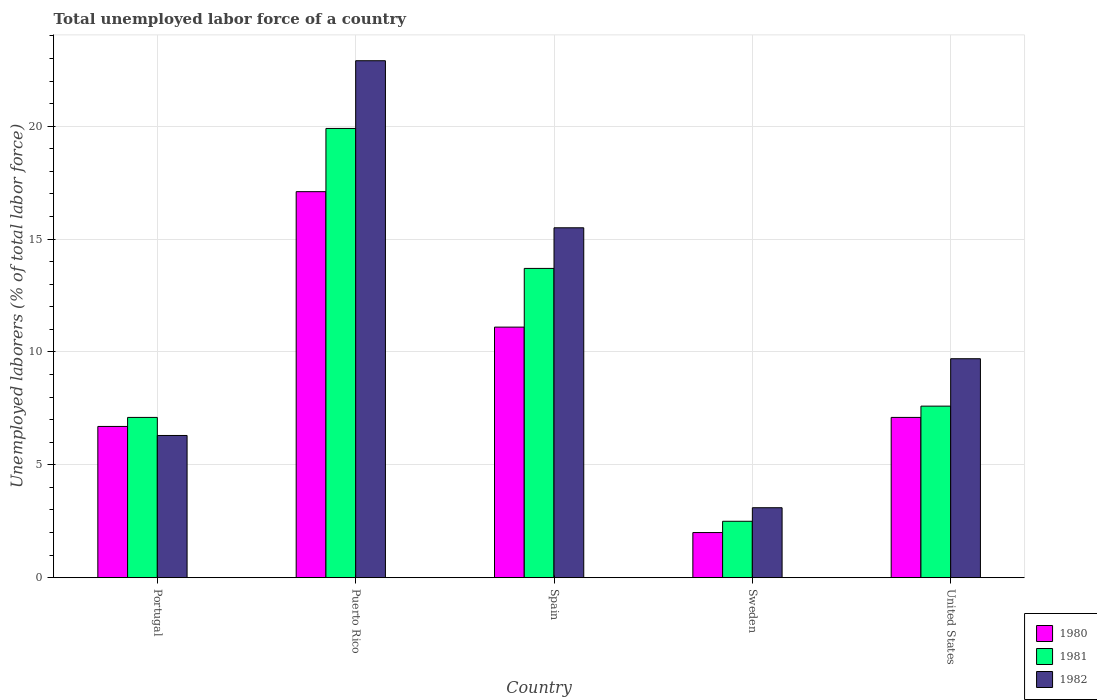Are the number of bars per tick equal to the number of legend labels?
Ensure brevity in your answer.  Yes. Are the number of bars on each tick of the X-axis equal?
Make the answer very short. Yes. How many bars are there on the 4th tick from the left?
Your response must be concise. 3. In how many cases, is the number of bars for a given country not equal to the number of legend labels?
Provide a short and direct response. 0. What is the total unemployed labor force in 1982 in Portugal?
Keep it short and to the point. 6.3. Across all countries, what is the maximum total unemployed labor force in 1980?
Your response must be concise. 17.1. In which country was the total unemployed labor force in 1982 maximum?
Provide a short and direct response. Puerto Rico. In which country was the total unemployed labor force in 1980 minimum?
Your answer should be very brief. Sweden. What is the total total unemployed labor force in 1982 in the graph?
Your answer should be very brief. 57.5. What is the difference between the total unemployed labor force in 1980 in Spain and that in Sweden?
Give a very brief answer. 9.1. What is the difference between the total unemployed labor force in 1981 in Portugal and the total unemployed labor force in 1982 in Puerto Rico?
Make the answer very short. -15.8. What is the average total unemployed labor force in 1980 per country?
Offer a very short reply. 8.8. What is the difference between the total unemployed labor force of/in 1980 and total unemployed labor force of/in 1982 in Portugal?
Your answer should be very brief. 0.4. What is the ratio of the total unemployed labor force in 1982 in Puerto Rico to that in United States?
Your answer should be compact. 2.36. Is the total unemployed labor force in 1982 in Portugal less than that in United States?
Your answer should be very brief. Yes. What is the difference between the highest and the second highest total unemployed labor force in 1980?
Your answer should be very brief. 6. What is the difference between the highest and the lowest total unemployed labor force in 1981?
Your answer should be compact. 17.4. In how many countries, is the total unemployed labor force in 1982 greater than the average total unemployed labor force in 1982 taken over all countries?
Keep it short and to the point. 2. What does the 3rd bar from the right in United States represents?
Ensure brevity in your answer.  1980. Are all the bars in the graph horizontal?
Your answer should be very brief. No. How many countries are there in the graph?
Offer a terse response. 5. What is the difference between two consecutive major ticks on the Y-axis?
Give a very brief answer. 5. What is the title of the graph?
Ensure brevity in your answer.  Total unemployed labor force of a country. What is the label or title of the Y-axis?
Give a very brief answer. Unemployed laborers (% of total labor force). What is the Unemployed laborers (% of total labor force) of 1980 in Portugal?
Ensure brevity in your answer.  6.7. What is the Unemployed laborers (% of total labor force) of 1981 in Portugal?
Your answer should be compact. 7.1. What is the Unemployed laborers (% of total labor force) in 1982 in Portugal?
Your response must be concise. 6.3. What is the Unemployed laborers (% of total labor force) of 1980 in Puerto Rico?
Offer a very short reply. 17.1. What is the Unemployed laborers (% of total labor force) in 1981 in Puerto Rico?
Your answer should be compact. 19.9. What is the Unemployed laborers (% of total labor force) of 1982 in Puerto Rico?
Your answer should be very brief. 22.9. What is the Unemployed laborers (% of total labor force) in 1980 in Spain?
Make the answer very short. 11.1. What is the Unemployed laborers (% of total labor force) of 1981 in Spain?
Your answer should be very brief. 13.7. What is the Unemployed laborers (% of total labor force) of 1982 in Sweden?
Provide a succinct answer. 3.1. What is the Unemployed laborers (% of total labor force) of 1980 in United States?
Make the answer very short. 7.1. What is the Unemployed laborers (% of total labor force) in 1981 in United States?
Your answer should be compact. 7.6. What is the Unemployed laborers (% of total labor force) of 1982 in United States?
Give a very brief answer. 9.7. Across all countries, what is the maximum Unemployed laborers (% of total labor force) in 1980?
Provide a short and direct response. 17.1. Across all countries, what is the maximum Unemployed laborers (% of total labor force) of 1981?
Keep it short and to the point. 19.9. Across all countries, what is the maximum Unemployed laborers (% of total labor force) in 1982?
Give a very brief answer. 22.9. Across all countries, what is the minimum Unemployed laborers (% of total labor force) in 1982?
Your answer should be compact. 3.1. What is the total Unemployed laborers (% of total labor force) in 1980 in the graph?
Keep it short and to the point. 44. What is the total Unemployed laborers (% of total labor force) of 1981 in the graph?
Your response must be concise. 50.8. What is the total Unemployed laborers (% of total labor force) in 1982 in the graph?
Make the answer very short. 57.5. What is the difference between the Unemployed laborers (% of total labor force) of 1982 in Portugal and that in Puerto Rico?
Provide a short and direct response. -16.6. What is the difference between the Unemployed laborers (% of total labor force) of 1981 in Portugal and that in Spain?
Your answer should be compact. -6.6. What is the difference between the Unemployed laborers (% of total labor force) of 1981 in Portugal and that in Sweden?
Give a very brief answer. 4.6. What is the difference between the Unemployed laborers (% of total labor force) of 1982 in Portugal and that in Sweden?
Your answer should be very brief. 3.2. What is the difference between the Unemployed laborers (% of total labor force) of 1980 in Portugal and that in United States?
Your answer should be very brief. -0.4. What is the difference between the Unemployed laborers (% of total labor force) of 1981 in Portugal and that in United States?
Your answer should be compact. -0.5. What is the difference between the Unemployed laborers (% of total labor force) of 1981 in Puerto Rico and that in Spain?
Your answer should be compact. 6.2. What is the difference between the Unemployed laborers (% of total labor force) of 1982 in Puerto Rico and that in Sweden?
Keep it short and to the point. 19.8. What is the difference between the Unemployed laborers (% of total labor force) in 1982 in Puerto Rico and that in United States?
Give a very brief answer. 13.2. What is the difference between the Unemployed laborers (% of total labor force) in 1982 in Spain and that in Sweden?
Your answer should be compact. 12.4. What is the difference between the Unemployed laborers (% of total labor force) in 1980 in Sweden and that in United States?
Make the answer very short. -5.1. What is the difference between the Unemployed laborers (% of total labor force) of 1981 in Sweden and that in United States?
Make the answer very short. -5.1. What is the difference between the Unemployed laborers (% of total labor force) of 1980 in Portugal and the Unemployed laborers (% of total labor force) of 1981 in Puerto Rico?
Provide a succinct answer. -13.2. What is the difference between the Unemployed laborers (% of total labor force) in 1980 in Portugal and the Unemployed laborers (% of total labor force) in 1982 in Puerto Rico?
Your answer should be very brief. -16.2. What is the difference between the Unemployed laborers (% of total labor force) of 1981 in Portugal and the Unemployed laborers (% of total labor force) of 1982 in Puerto Rico?
Your answer should be very brief. -15.8. What is the difference between the Unemployed laborers (% of total labor force) of 1980 in Portugal and the Unemployed laborers (% of total labor force) of 1982 in Spain?
Offer a very short reply. -8.8. What is the difference between the Unemployed laborers (% of total labor force) in 1981 in Portugal and the Unemployed laborers (% of total labor force) in 1982 in Spain?
Keep it short and to the point. -8.4. What is the difference between the Unemployed laborers (% of total labor force) in 1980 in Portugal and the Unemployed laborers (% of total labor force) in 1981 in Sweden?
Offer a very short reply. 4.2. What is the difference between the Unemployed laborers (% of total labor force) of 1980 in Portugal and the Unemployed laborers (% of total labor force) of 1982 in Sweden?
Your response must be concise. 3.6. What is the difference between the Unemployed laborers (% of total labor force) of 1981 in Portugal and the Unemployed laborers (% of total labor force) of 1982 in Sweden?
Provide a short and direct response. 4. What is the difference between the Unemployed laborers (% of total labor force) of 1980 in Portugal and the Unemployed laborers (% of total labor force) of 1981 in United States?
Make the answer very short. -0.9. What is the difference between the Unemployed laborers (% of total labor force) in 1980 in Portugal and the Unemployed laborers (% of total labor force) in 1982 in United States?
Provide a succinct answer. -3. What is the difference between the Unemployed laborers (% of total labor force) of 1980 in Puerto Rico and the Unemployed laborers (% of total labor force) of 1981 in Spain?
Give a very brief answer. 3.4. What is the difference between the Unemployed laborers (% of total labor force) of 1980 in Puerto Rico and the Unemployed laborers (% of total labor force) of 1982 in Spain?
Your answer should be very brief. 1.6. What is the difference between the Unemployed laborers (% of total labor force) of 1981 in Puerto Rico and the Unemployed laborers (% of total labor force) of 1982 in Spain?
Give a very brief answer. 4.4. What is the difference between the Unemployed laborers (% of total labor force) in 1981 in Puerto Rico and the Unemployed laborers (% of total labor force) in 1982 in Sweden?
Keep it short and to the point. 16.8. What is the difference between the Unemployed laborers (% of total labor force) of 1980 in Puerto Rico and the Unemployed laborers (% of total labor force) of 1981 in United States?
Provide a succinct answer. 9.5. What is the difference between the Unemployed laborers (% of total labor force) in 1980 in Spain and the Unemployed laborers (% of total labor force) in 1982 in United States?
Keep it short and to the point. 1.4. What is the difference between the Unemployed laborers (% of total labor force) of 1981 in Spain and the Unemployed laborers (% of total labor force) of 1982 in United States?
Your response must be concise. 4. What is the difference between the Unemployed laborers (% of total labor force) of 1980 in Sweden and the Unemployed laborers (% of total labor force) of 1982 in United States?
Ensure brevity in your answer.  -7.7. What is the difference between the Unemployed laborers (% of total labor force) in 1981 in Sweden and the Unemployed laborers (% of total labor force) in 1982 in United States?
Offer a very short reply. -7.2. What is the average Unemployed laborers (% of total labor force) of 1980 per country?
Your response must be concise. 8.8. What is the average Unemployed laborers (% of total labor force) in 1981 per country?
Ensure brevity in your answer.  10.16. What is the difference between the Unemployed laborers (% of total labor force) of 1980 and Unemployed laborers (% of total labor force) of 1982 in Portugal?
Provide a short and direct response. 0.4. What is the difference between the Unemployed laborers (% of total labor force) in 1981 and Unemployed laborers (% of total labor force) in 1982 in Portugal?
Your answer should be very brief. 0.8. What is the difference between the Unemployed laborers (% of total labor force) of 1980 and Unemployed laborers (% of total labor force) of 1981 in Puerto Rico?
Your answer should be compact. -2.8. What is the difference between the Unemployed laborers (% of total labor force) of 1981 and Unemployed laborers (% of total labor force) of 1982 in Puerto Rico?
Provide a succinct answer. -3. What is the difference between the Unemployed laborers (% of total labor force) in 1980 and Unemployed laborers (% of total labor force) in 1981 in Spain?
Give a very brief answer. -2.6. What is the difference between the Unemployed laborers (% of total labor force) of 1981 and Unemployed laborers (% of total labor force) of 1982 in Sweden?
Your answer should be compact. -0.6. What is the ratio of the Unemployed laborers (% of total labor force) in 1980 in Portugal to that in Puerto Rico?
Offer a very short reply. 0.39. What is the ratio of the Unemployed laborers (% of total labor force) in 1981 in Portugal to that in Puerto Rico?
Your answer should be very brief. 0.36. What is the ratio of the Unemployed laborers (% of total labor force) in 1982 in Portugal to that in Puerto Rico?
Provide a succinct answer. 0.28. What is the ratio of the Unemployed laborers (% of total labor force) in 1980 in Portugal to that in Spain?
Your response must be concise. 0.6. What is the ratio of the Unemployed laborers (% of total labor force) of 1981 in Portugal to that in Spain?
Your response must be concise. 0.52. What is the ratio of the Unemployed laborers (% of total labor force) in 1982 in Portugal to that in Spain?
Offer a very short reply. 0.41. What is the ratio of the Unemployed laborers (% of total labor force) in 1980 in Portugal to that in Sweden?
Your response must be concise. 3.35. What is the ratio of the Unemployed laborers (% of total labor force) in 1981 in Portugal to that in Sweden?
Give a very brief answer. 2.84. What is the ratio of the Unemployed laborers (% of total labor force) in 1982 in Portugal to that in Sweden?
Offer a terse response. 2.03. What is the ratio of the Unemployed laborers (% of total labor force) in 1980 in Portugal to that in United States?
Make the answer very short. 0.94. What is the ratio of the Unemployed laborers (% of total labor force) in 1981 in Portugal to that in United States?
Offer a very short reply. 0.93. What is the ratio of the Unemployed laborers (% of total labor force) in 1982 in Portugal to that in United States?
Provide a short and direct response. 0.65. What is the ratio of the Unemployed laborers (% of total labor force) of 1980 in Puerto Rico to that in Spain?
Your answer should be compact. 1.54. What is the ratio of the Unemployed laborers (% of total labor force) of 1981 in Puerto Rico to that in Spain?
Your response must be concise. 1.45. What is the ratio of the Unemployed laborers (% of total labor force) of 1982 in Puerto Rico to that in Spain?
Give a very brief answer. 1.48. What is the ratio of the Unemployed laborers (% of total labor force) in 1980 in Puerto Rico to that in Sweden?
Your answer should be very brief. 8.55. What is the ratio of the Unemployed laborers (% of total labor force) in 1981 in Puerto Rico to that in Sweden?
Keep it short and to the point. 7.96. What is the ratio of the Unemployed laborers (% of total labor force) of 1982 in Puerto Rico to that in Sweden?
Provide a succinct answer. 7.39. What is the ratio of the Unemployed laborers (% of total labor force) of 1980 in Puerto Rico to that in United States?
Offer a very short reply. 2.41. What is the ratio of the Unemployed laborers (% of total labor force) of 1981 in Puerto Rico to that in United States?
Offer a terse response. 2.62. What is the ratio of the Unemployed laborers (% of total labor force) in 1982 in Puerto Rico to that in United States?
Give a very brief answer. 2.36. What is the ratio of the Unemployed laborers (% of total labor force) in 1980 in Spain to that in Sweden?
Make the answer very short. 5.55. What is the ratio of the Unemployed laborers (% of total labor force) in 1981 in Spain to that in Sweden?
Your answer should be very brief. 5.48. What is the ratio of the Unemployed laborers (% of total labor force) of 1982 in Spain to that in Sweden?
Offer a terse response. 5. What is the ratio of the Unemployed laborers (% of total labor force) in 1980 in Spain to that in United States?
Provide a short and direct response. 1.56. What is the ratio of the Unemployed laborers (% of total labor force) in 1981 in Spain to that in United States?
Provide a short and direct response. 1.8. What is the ratio of the Unemployed laborers (% of total labor force) of 1982 in Spain to that in United States?
Provide a short and direct response. 1.6. What is the ratio of the Unemployed laborers (% of total labor force) of 1980 in Sweden to that in United States?
Provide a succinct answer. 0.28. What is the ratio of the Unemployed laborers (% of total labor force) of 1981 in Sweden to that in United States?
Provide a succinct answer. 0.33. What is the ratio of the Unemployed laborers (% of total labor force) in 1982 in Sweden to that in United States?
Your response must be concise. 0.32. What is the difference between the highest and the second highest Unemployed laborers (% of total labor force) in 1981?
Offer a very short reply. 6.2. What is the difference between the highest and the second highest Unemployed laborers (% of total labor force) in 1982?
Keep it short and to the point. 7.4. What is the difference between the highest and the lowest Unemployed laborers (% of total labor force) of 1980?
Make the answer very short. 15.1. What is the difference between the highest and the lowest Unemployed laborers (% of total labor force) of 1981?
Make the answer very short. 17.4. What is the difference between the highest and the lowest Unemployed laborers (% of total labor force) in 1982?
Provide a short and direct response. 19.8. 